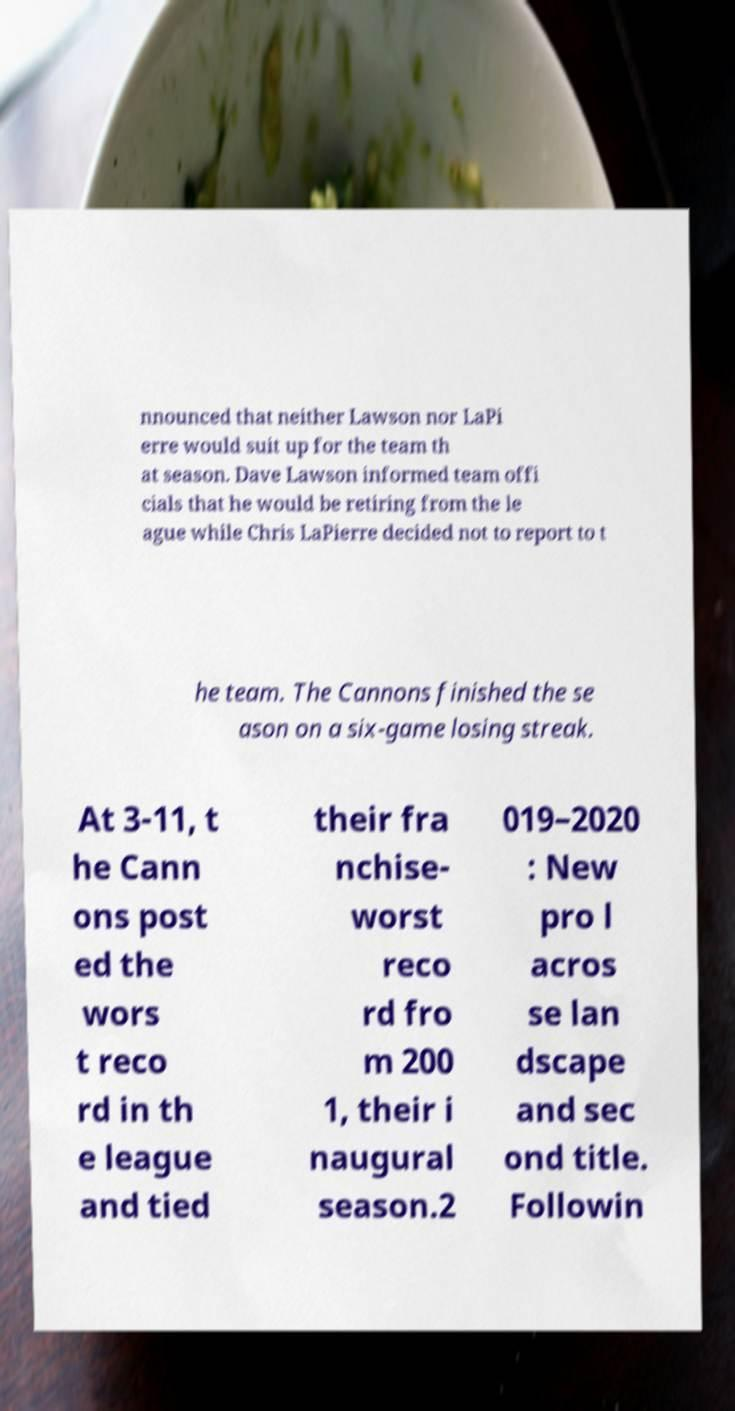Can you accurately transcribe the text from the provided image for me? nnounced that neither Lawson nor LaPi erre would suit up for the team th at season. Dave Lawson informed team offi cials that he would be retiring from the le ague while Chris LaPierre decided not to report to t he team. The Cannons finished the se ason on a six-game losing streak. At 3-11, t he Cann ons post ed the wors t reco rd in th e league and tied their fra nchise- worst reco rd fro m 200 1, their i naugural season.2 019–2020 : New pro l acros se lan dscape and sec ond title. Followin 